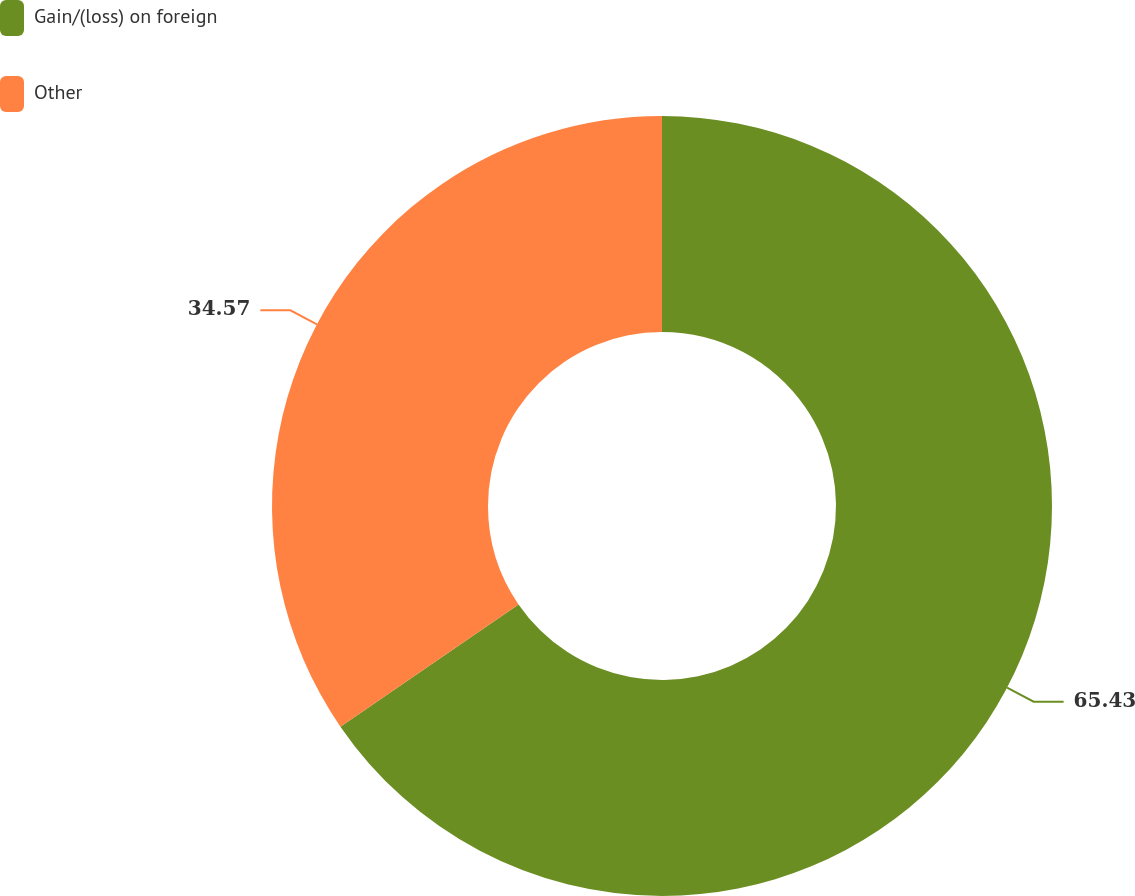Convert chart to OTSL. <chart><loc_0><loc_0><loc_500><loc_500><pie_chart><fcel>Gain/(loss) on foreign<fcel>Other<nl><fcel>65.43%<fcel>34.57%<nl></chart> 